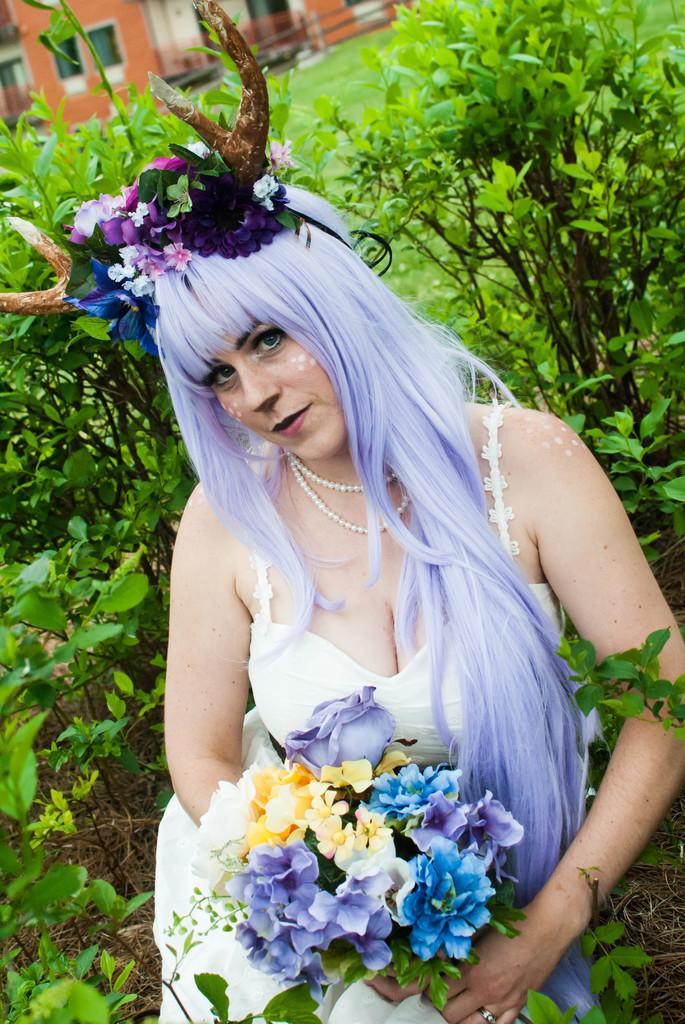In one or two sentences, can you explain what this image depicts? In this image I can see a woman holding bunch of flowers and she wearing a colorful wig on her head , back side of her I can see plants and the house 